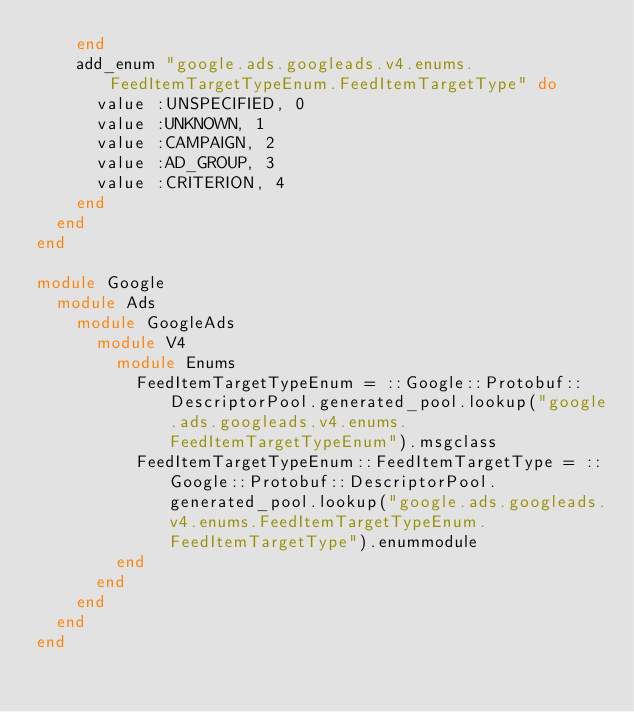Convert code to text. <code><loc_0><loc_0><loc_500><loc_500><_Ruby_>    end
    add_enum "google.ads.googleads.v4.enums.FeedItemTargetTypeEnum.FeedItemTargetType" do
      value :UNSPECIFIED, 0
      value :UNKNOWN, 1
      value :CAMPAIGN, 2
      value :AD_GROUP, 3
      value :CRITERION, 4
    end
  end
end

module Google
  module Ads
    module GoogleAds
      module V4
        module Enums
          FeedItemTargetTypeEnum = ::Google::Protobuf::DescriptorPool.generated_pool.lookup("google.ads.googleads.v4.enums.FeedItemTargetTypeEnum").msgclass
          FeedItemTargetTypeEnum::FeedItemTargetType = ::Google::Protobuf::DescriptorPool.generated_pool.lookup("google.ads.googleads.v4.enums.FeedItemTargetTypeEnum.FeedItemTargetType").enummodule
        end
      end
    end
  end
end
</code> 